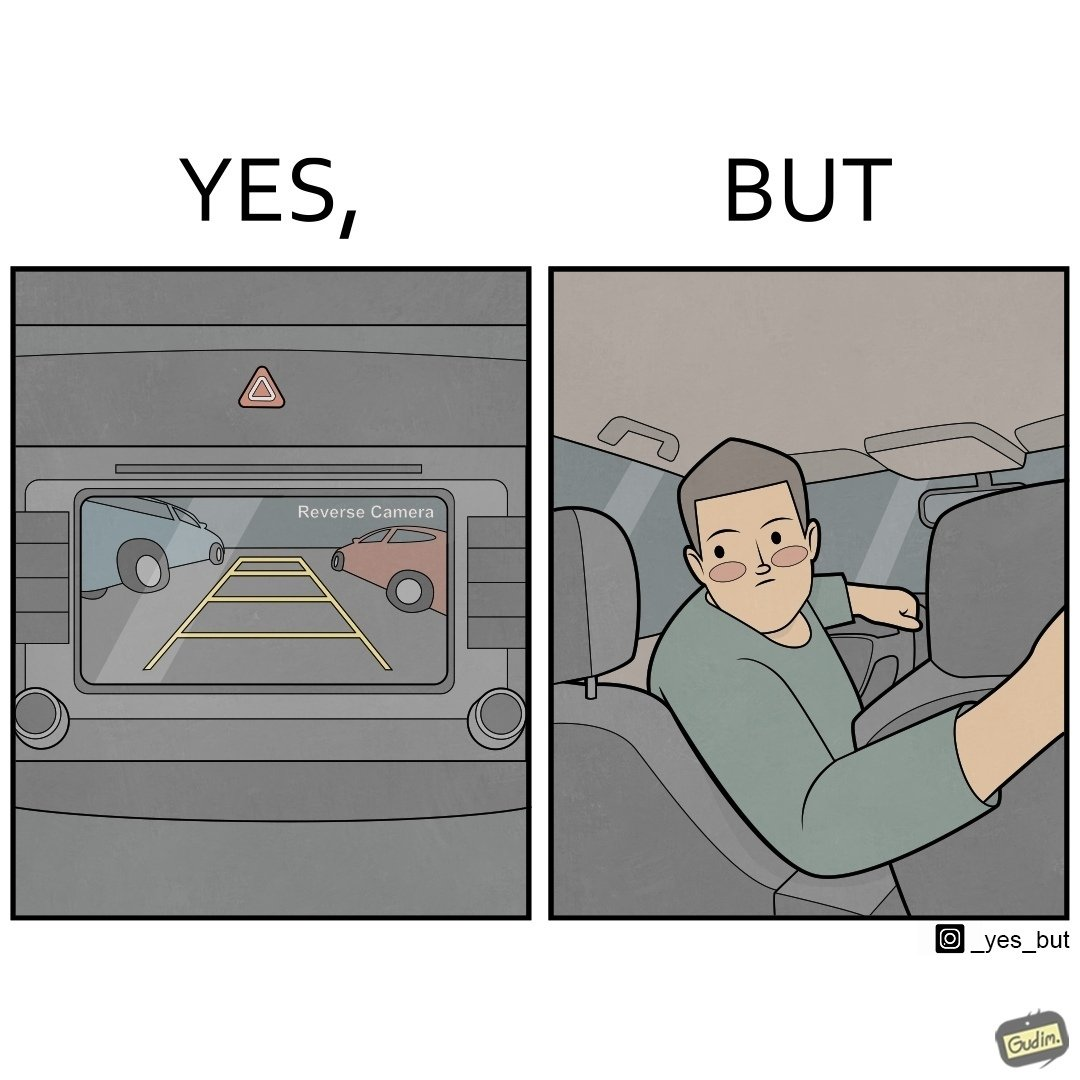What is shown in this image? The images are funny since even it shows how even though modern cars are fitted with features like reverse camera, drivers still choose to not use it and reverse the old fashioned way by looking behind 